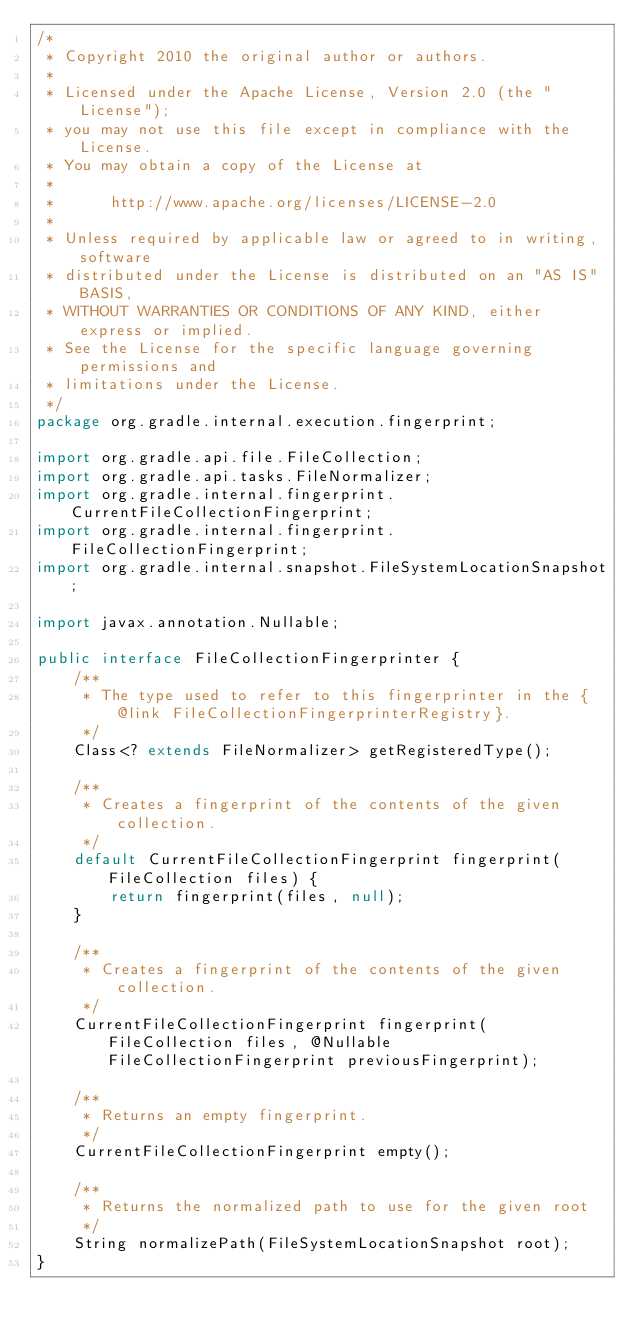Convert code to text. <code><loc_0><loc_0><loc_500><loc_500><_Java_>/*
 * Copyright 2010 the original author or authors.
 *
 * Licensed under the Apache License, Version 2.0 (the "License");
 * you may not use this file except in compliance with the License.
 * You may obtain a copy of the License at
 *
 *      http://www.apache.org/licenses/LICENSE-2.0
 *
 * Unless required by applicable law or agreed to in writing, software
 * distributed under the License is distributed on an "AS IS" BASIS,
 * WITHOUT WARRANTIES OR CONDITIONS OF ANY KIND, either express or implied.
 * See the License for the specific language governing permissions and
 * limitations under the License.
 */
package org.gradle.internal.execution.fingerprint;

import org.gradle.api.file.FileCollection;
import org.gradle.api.tasks.FileNormalizer;
import org.gradle.internal.fingerprint.CurrentFileCollectionFingerprint;
import org.gradle.internal.fingerprint.FileCollectionFingerprint;
import org.gradle.internal.snapshot.FileSystemLocationSnapshot;

import javax.annotation.Nullable;

public interface FileCollectionFingerprinter {
    /**
     * The type used to refer to this fingerprinter in the {@link FileCollectionFingerprinterRegistry}.
     */
    Class<? extends FileNormalizer> getRegisteredType();

    /**
     * Creates a fingerprint of the contents of the given collection.
     */
    default CurrentFileCollectionFingerprint fingerprint(FileCollection files) {
        return fingerprint(files, null);
    }

    /**
     * Creates a fingerprint of the contents of the given collection.
     */
    CurrentFileCollectionFingerprint fingerprint(FileCollection files, @Nullable FileCollectionFingerprint previousFingerprint);

    /**
     * Returns an empty fingerprint.
     */
    CurrentFileCollectionFingerprint empty();

    /**
     * Returns the normalized path to use for the given root
     */
    String normalizePath(FileSystemLocationSnapshot root);
}
</code> 